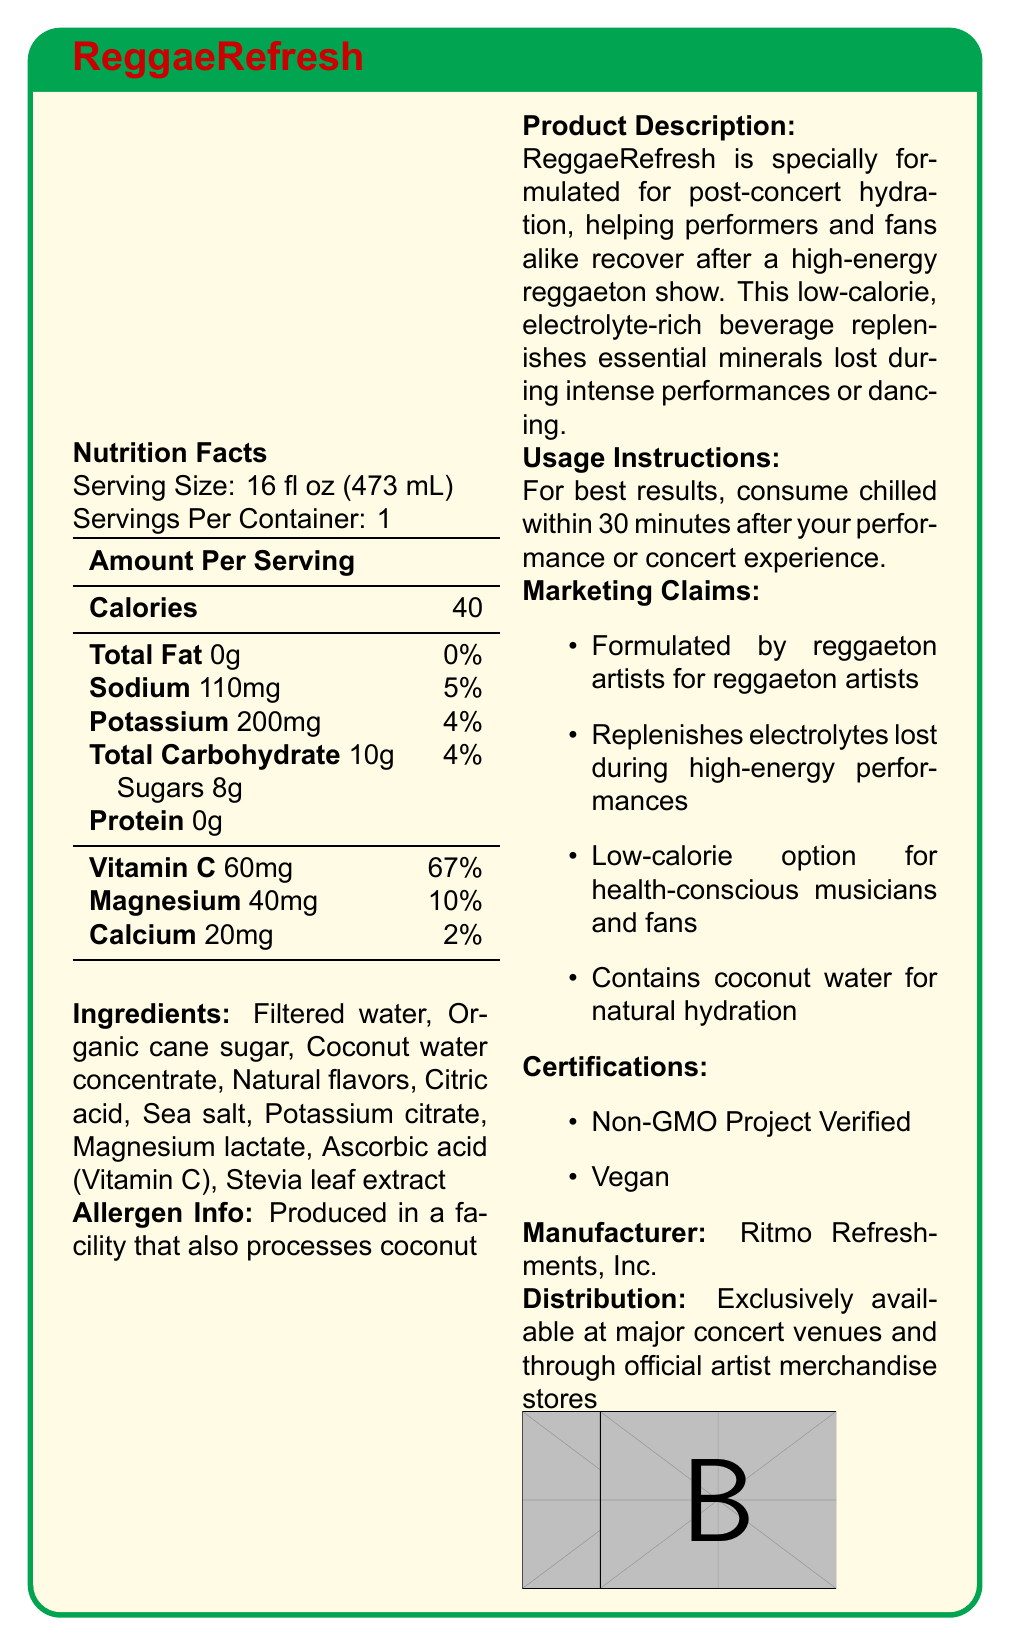What is the serving size of ReggaeRefresh? The serving size is explicitly listed in the first section under "Nutrition Facts".
Answer: 16 fl oz (473 mL) How many servings are in one container? The document states "Servings Per Container: 1".
Answer: 1 How many calories are in a serving of ReggaeRefresh? The number of calories per serving is listed in the Nutrition Facts table as 40.
Answer: 40 Which electrolyte has the highest daily value percentage in ReggaeRefresh? The daily value percentage of Vitamin C is the highest at 67% compared to other electrolytes like Sodium and Potassium.
Answer: Vitamin C (67%) What are the main ingredients in ReggaeRefresh? These ingredients are listed under the "Ingredients" section.
Answer: Filtered water, Organic cane sugar, Coconut water concentrate, Natural flavors, Citric acid, Sea salt, Potassium citrate, Magnesium lactate, Ascorbic acid (Vitamin C), Stevia leaf extract Which mineral is NOT part of ReggaeRefresh's ingredient list? A. Calcium B. Sodium C. Zinc D. Magnesium Zinc is not listed as an ingredient, whereas Calcium, Sodium, and Magnesium are mentioned in the ingredient list and Nutrition Facts.
Answer: C. Zinc What is the brand of the recovery beverage? A. HydratePlus B. ReggaeRefresh C. ElectroFizz D. ConcertHydrate The product name is given as “ReggaeRefresh” in the title and Product Description.
Answer: B. ReggaeRefresh Which certification does ReggaeRefresh have? A. Organic B. Non-GMO Project Verified C. Gluten-Free D. Kosher The certification "Non-GMO Project Verified" is listed under the "Certifications" section.
Answer: B. Non-GMO Project Verified Is ReggaeRefresh a low-calorie beverage? The document explicitly states that it is a low-calorie beverage.
Answer: Yes Summarize the main purpose and unique selling points of ReggaeRefresh. The document states that ReggaeRefresh is aimed at post-concert hydration, helping to recover essential minerals, and is formulated by reggaeton artists. It highlights low calories and natural hydration from coconut water as key benefits.
Answer: ReggaeRefresh is a low-calorie, electrolyte-rich beverage designed for post-concert hydration to help performers and fans recover after high-energy reggaeton shows. It replenishes essential minerals lost during intense activities, contains coconut water for natural hydration, and is formulated specifically by and for reggaeton artists. What is the daily value percentage of Sodium in one serving? The document states that Sodium constitutes 5% of the daily value.
Answer: 5% What are the usage instructions for ReggaeRefresh? The usage instructions are explicitly mentioned in the corresponding section of the document.
Answer: For best results, consume chilled within 30 minutes after your performance or concert experience. Without external references, what is the price of ReggaeRefresh? The document does not provide any details on the price of the beverage.
Answer: Not enough information 